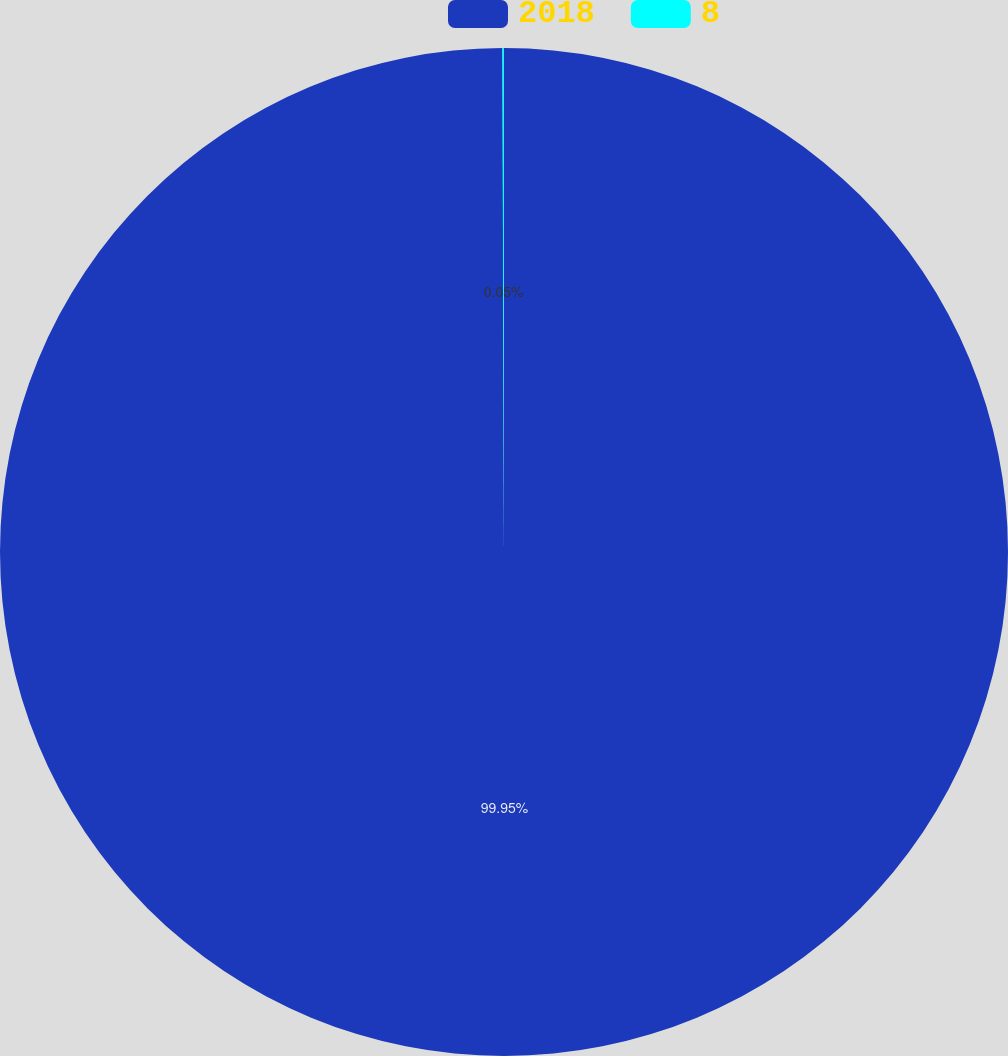<chart> <loc_0><loc_0><loc_500><loc_500><pie_chart><fcel>2018<fcel>8<nl><fcel>99.95%<fcel>0.05%<nl></chart> 